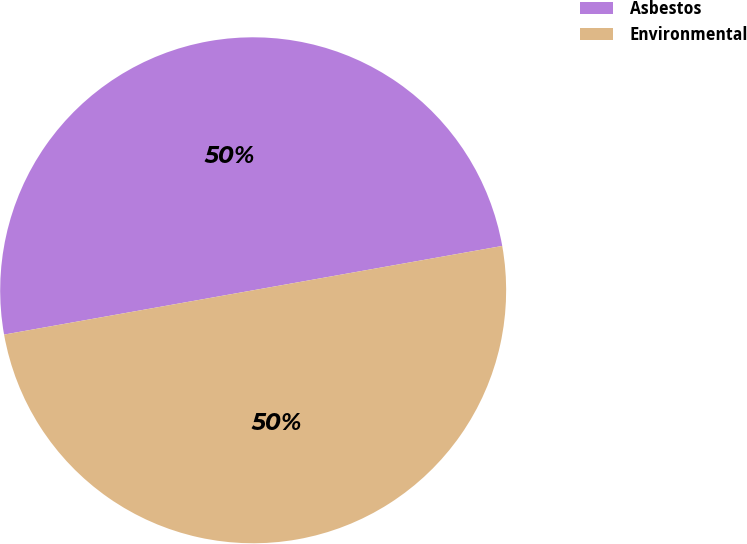<chart> <loc_0><loc_0><loc_500><loc_500><pie_chart><fcel>Asbestos<fcel>Environmental<nl><fcel>50.0%<fcel>50.0%<nl></chart> 